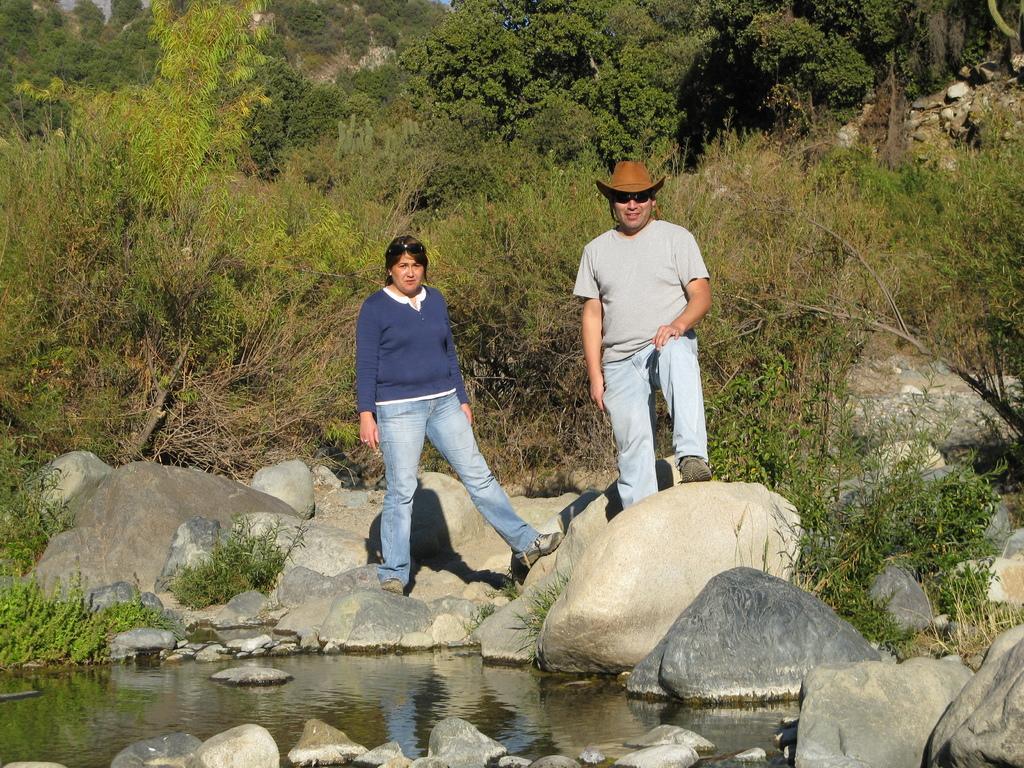Describe this image in one or two sentences. This picture is clicked outside. In the center we can see the two persons wearing t-shirts and standing on the rocks and we can see a water body, plants, trees and some other objects. 